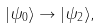Convert formula to latex. <formula><loc_0><loc_0><loc_500><loc_500>| \psi _ { 0 } \rangle \rightarrow | \psi _ { 2 } \rangle ,</formula> 